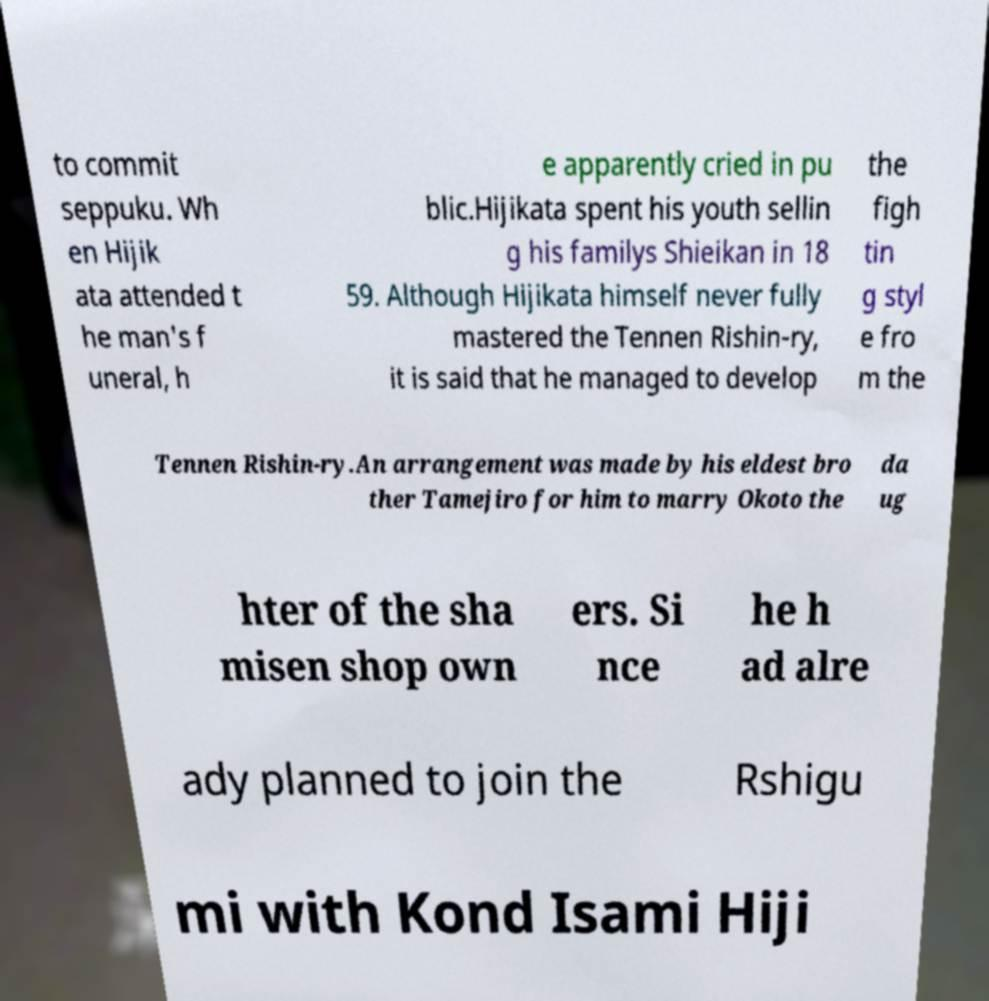Please identify and transcribe the text found in this image. to commit seppuku. Wh en Hijik ata attended t he man's f uneral, h e apparently cried in pu blic.Hijikata spent his youth sellin g his familys Shieikan in 18 59. Although Hijikata himself never fully mastered the Tennen Rishin-ry, it is said that he managed to develop the figh tin g styl e fro m the Tennen Rishin-ry.An arrangement was made by his eldest bro ther Tamejiro for him to marry Okoto the da ug hter of the sha misen shop own ers. Si nce he h ad alre ady planned to join the Rshigu mi with Kond Isami Hiji 